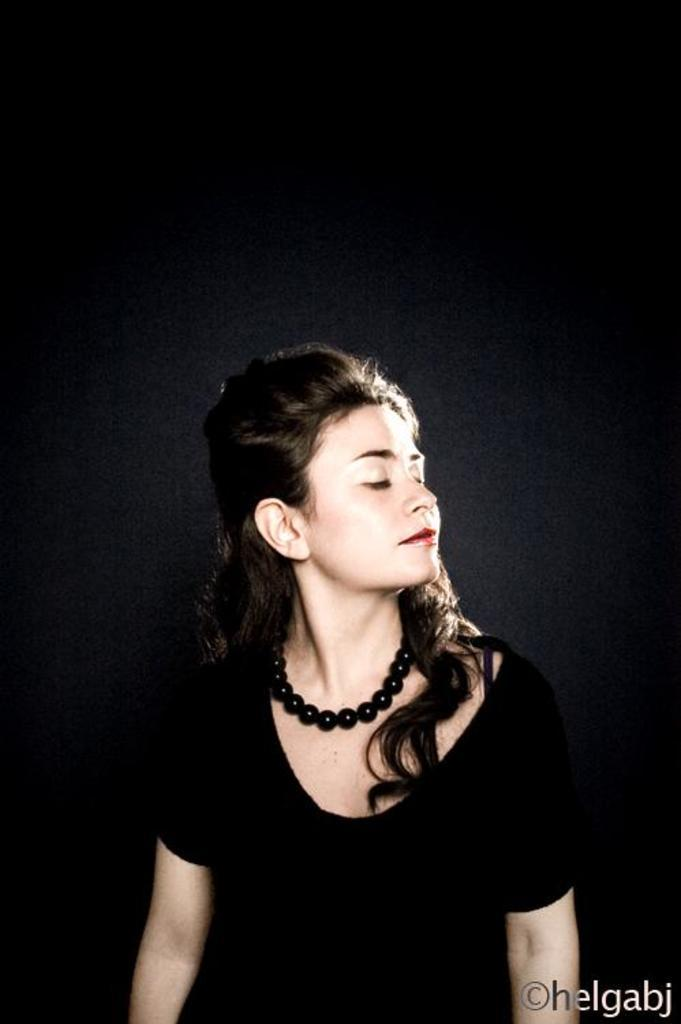Who is present in the image? There is a woman in the image. What is the woman wearing in the image? The woman is wearing a black chain in the image. What can be observed about the background of the image? The background of the image is dark. Where is the text located in the image? The text is in the bottom right side of the image. What type of cork can be seen in the woman's hair in the image? There is no cork present in the woman's hair or in the image. How many rays are visible in the image? There are no rays visible in the image. 